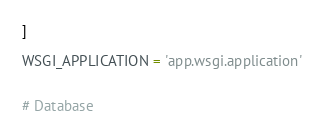<code> <loc_0><loc_0><loc_500><loc_500><_Python_>]

WSGI_APPLICATION = 'app.wsgi.application'


# Database</code> 